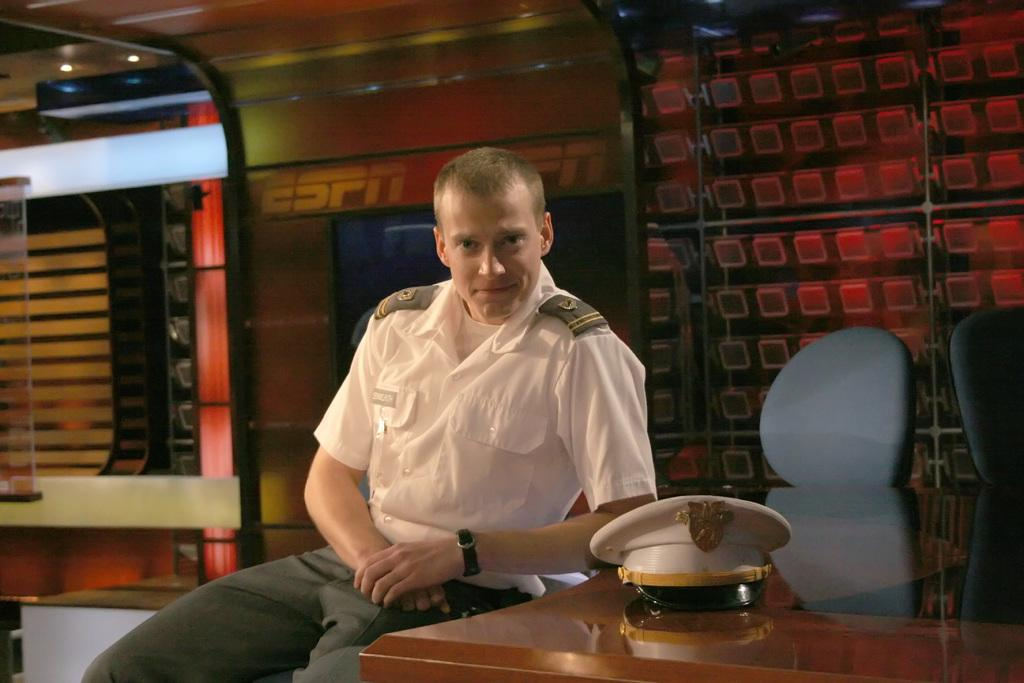What is the person in the image doing? The person is sitting on a chair in the image. What object is on the wooden table? There is a cap on the wooden table. How many chairs are visible in the image? There are multiple chairs visible in the image. What is illuminating the scene in the image? Lights are visible on top in the image. What type of ship can be seen sailing in the background of the image? There is no ship visible in the image; it only features a person sitting on a chair, a cap on a wooden table, multiple chairs, and lights. 